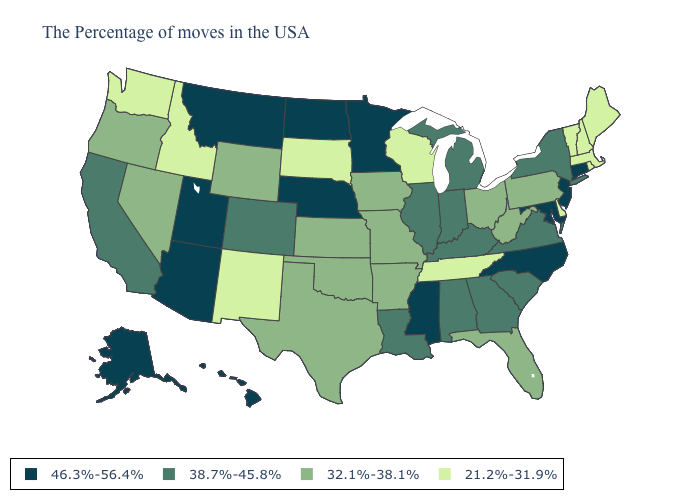Does Rhode Island have the highest value in the Northeast?
Short answer required. No. What is the value of Connecticut?
Concise answer only. 46.3%-56.4%. Name the states that have a value in the range 21.2%-31.9%?
Concise answer only. Maine, Massachusetts, Rhode Island, New Hampshire, Vermont, Delaware, Tennessee, Wisconsin, South Dakota, New Mexico, Idaho, Washington. Name the states that have a value in the range 46.3%-56.4%?
Concise answer only. Connecticut, New Jersey, Maryland, North Carolina, Mississippi, Minnesota, Nebraska, North Dakota, Utah, Montana, Arizona, Alaska, Hawaii. Among the states that border Oregon , which have the highest value?
Quick response, please. California. What is the lowest value in the USA?
Write a very short answer. 21.2%-31.9%. What is the lowest value in the USA?
Be succinct. 21.2%-31.9%. What is the value of Idaho?
Keep it brief. 21.2%-31.9%. Does the first symbol in the legend represent the smallest category?
Quick response, please. No. Name the states that have a value in the range 38.7%-45.8%?
Keep it brief. New York, Virginia, South Carolina, Georgia, Michigan, Kentucky, Indiana, Alabama, Illinois, Louisiana, Colorado, California. What is the value of Missouri?
Give a very brief answer. 32.1%-38.1%. Is the legend a continuous bar?
Be succinct. No. Which states have the lowest value in the USA?
Write a very short answer. Maine, Massachusetts, Rhode Island, New Hampshire, Vermont, Delaware, Tennessee, Wisconsin, South Dakota, New Mexico, Idaho, Washington. Does Utah have the highest value in the West?
Write a very short answer. Yes. Which states hav the highest value in the MidWest?
Give a very brief answer. Minnesota, Nebraska, North Dakota. 